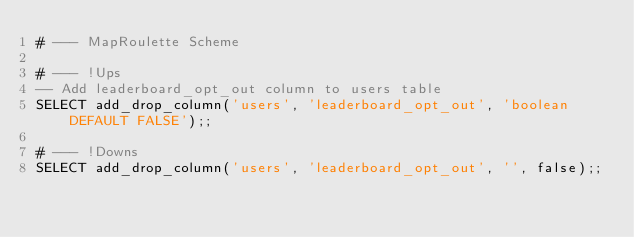Convert code to text. <code><loc_0><loc_0><loc_500><loc_500><_SQL_># --- MapRoulette Scheme

# --- !Ups
-- Add leaderboard_opt_out column to users table
SELECT add_drop_column('users', 'leaderboard_opt_out', 'boolean DEFAULT FALSE');;

# --- !Downs
SELECT add_drop_column('users', 'leaderboard_opt_out', '', false);;
</code> 